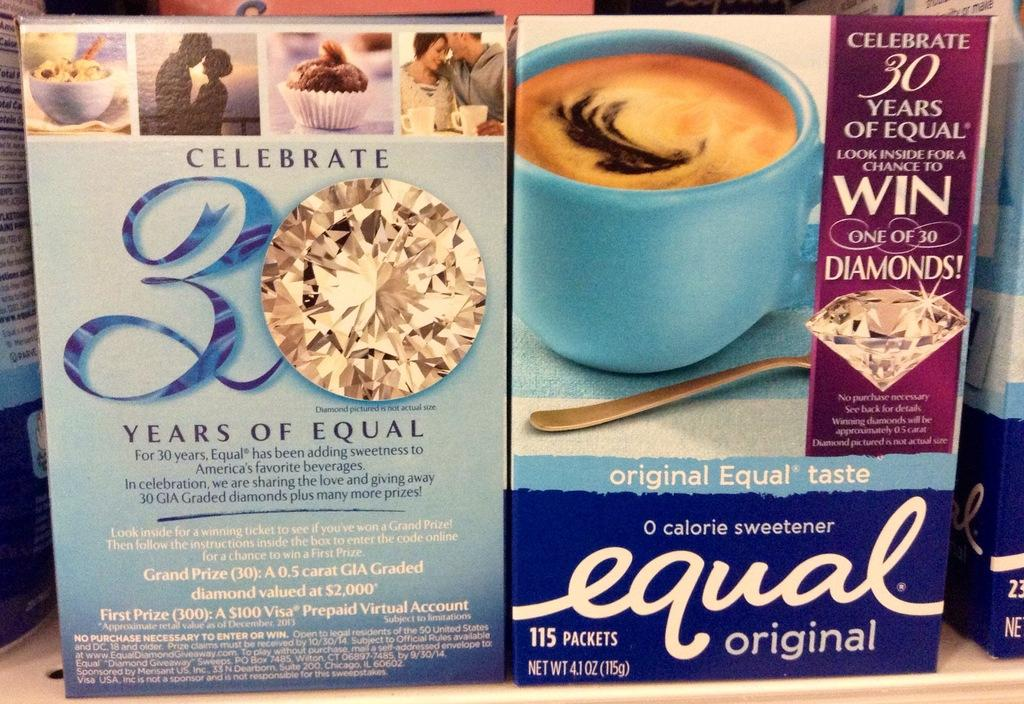<image>
Give a short and clear explanation of the subsequent image. A 0 calorie sweetener by the brad Equal in original. 